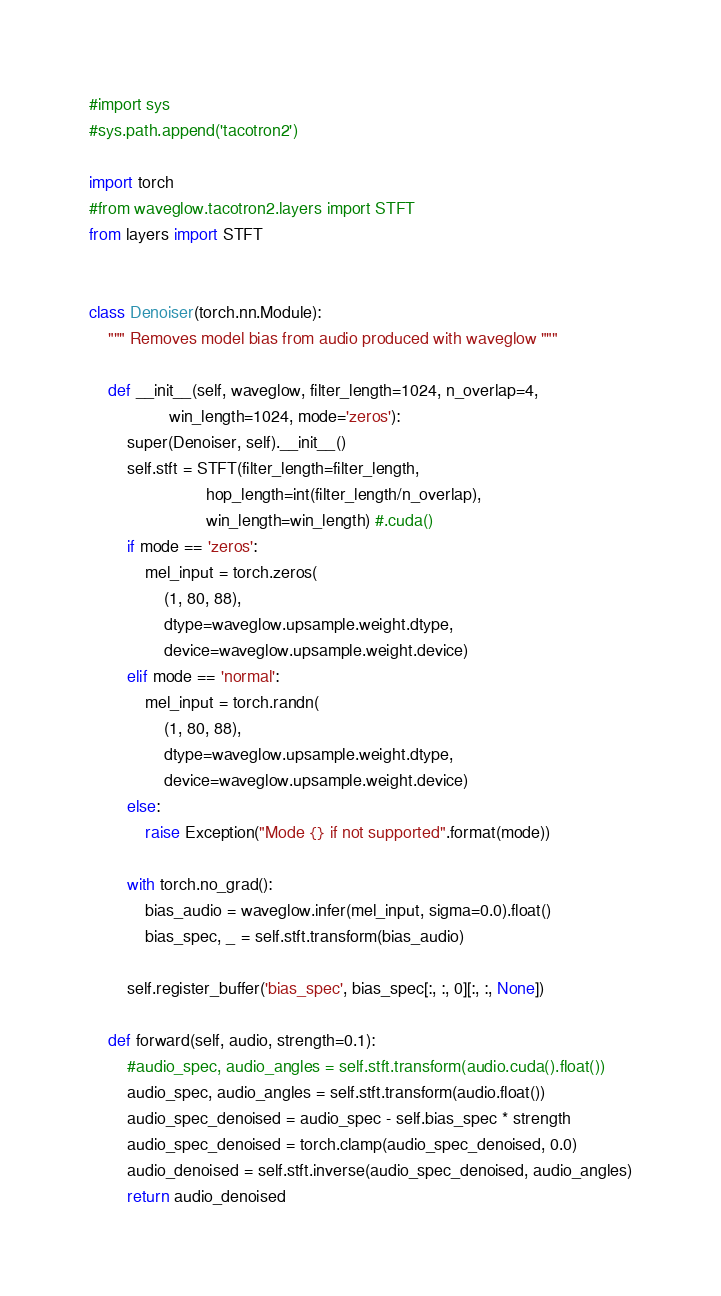Convert code to text. <code><loc_0><loc_0><loc_500><loc_500><_Python_>#import sys
#sys.path.append('tacotron2')

import torch
#from waveglow.tacotron2.layers import STFT
from layers import STFT


class Denoiser(torch.nn.Module):
    """ Removes model bias from audio produced with waveglow """

    def __init__(self, waveglow, filter_length=1024, n_overlap=4,
                 win_length=1024, mode='zeros'):
        super(Denoiser, self).__init__()
        self.stft = STFT(filter_length=filter_length,
                         hop_length=int(filter_length/n_overlap),
                         win_length=win_length) #.cuda()
        if mode == 'zeros':
            mel_input = torch.zeros(
                (1, 80, 88),
                dtype=waveglow.upsample.weight.dtype,
                device=waveglow.upsample.weight.device)
        elif mode == 'normal':
            mel_input = torch.randn(
                (1, 80, 88),
                dtype=waveglow.upsample.weight.dtype,
                device=waveglow.upsample.weight.device)
        else:
            raise Exception("Mode {} if not supported".format(mode))

        with torch.no_grad():
            bias_audio = waveglow.infer(mel_input, sigma=0.0).float()
            bias_spec, _ = self.stft.transform(bias_audio)

        self.register_buffer('bias_spec', bias_spec[:, :, 0][:, :, None])

    def forward(self, audio, strength=0.1):
        #audio_spec, audio_angles = self.stft.transform(audio.cuda().float())
        audio_spec, audio_angles = self.stft.transform(audio.float())
        audio_spec_denoised = audio_spec - self.bias_spec * strength
        audio_spec_denoised = torch.clamp(audio_spec_denoised, 0.0)
        audio_denoised = self.stft.inverse(audio_spec_denoised, audio_angles)
        return audio_denoised
</code> 